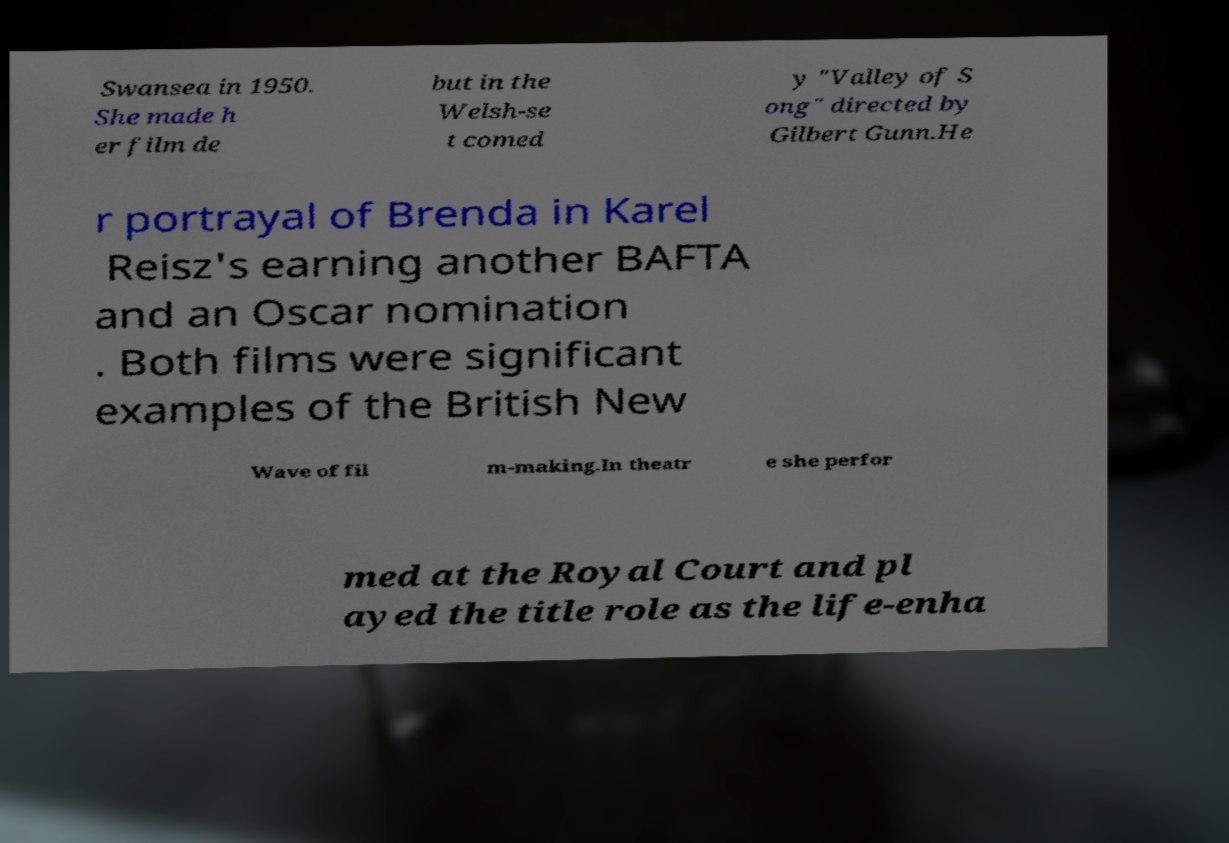There's text embedded in this image that I need extracted. Can you transcribe it verbatim? Swansea in 1950. She made h er film de but in the Welsh-se t comed y "Valley of S ong" directed by Gilbert Gunn.He r portrayal of Brenda in Karel Reisz's earning another BAFTA and an Oscar nomination . Both films were significant examples of the British New Wave of fil m-making.In theatr e she perfor med at the Royal Court and pl ayed the title role as the life-enha 